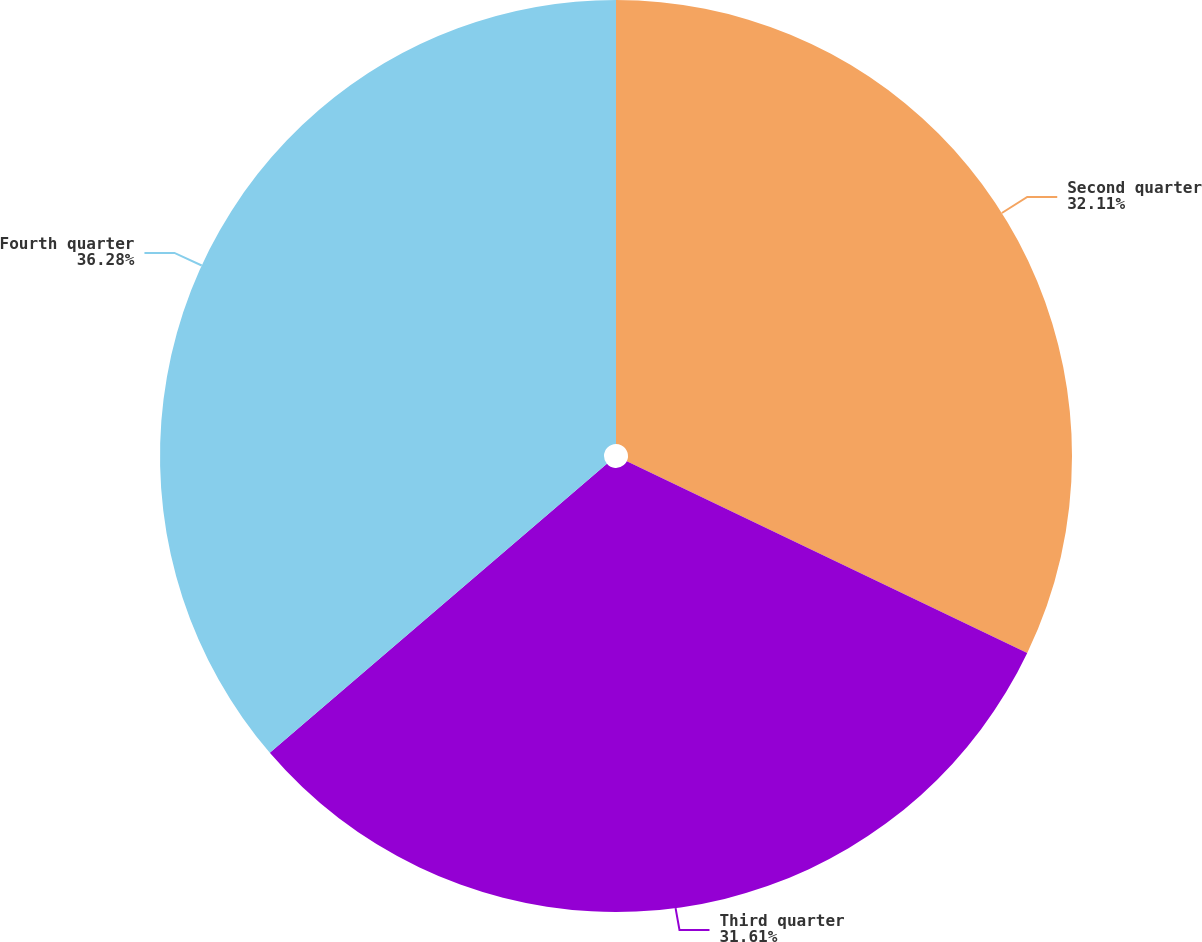<chart> <loc_0><loc_0><loc_500><loc_500><pie_chart><fcel>Second quarter<fcel>Third quarter<fcel>Fourth quarter<nl><fcel>32.11%<fcel>31.61%<fcel>36.28%<nl></chart> 